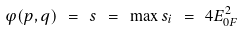Convert formula to latex. <formula><loc_0><loc_0><loc_500><loc_500>\varphi ( p , q ) \ = \ s \ = \ \max s _ { i } \ = \ 4 E ^ { 2 } _ { 0 F }</formula> 